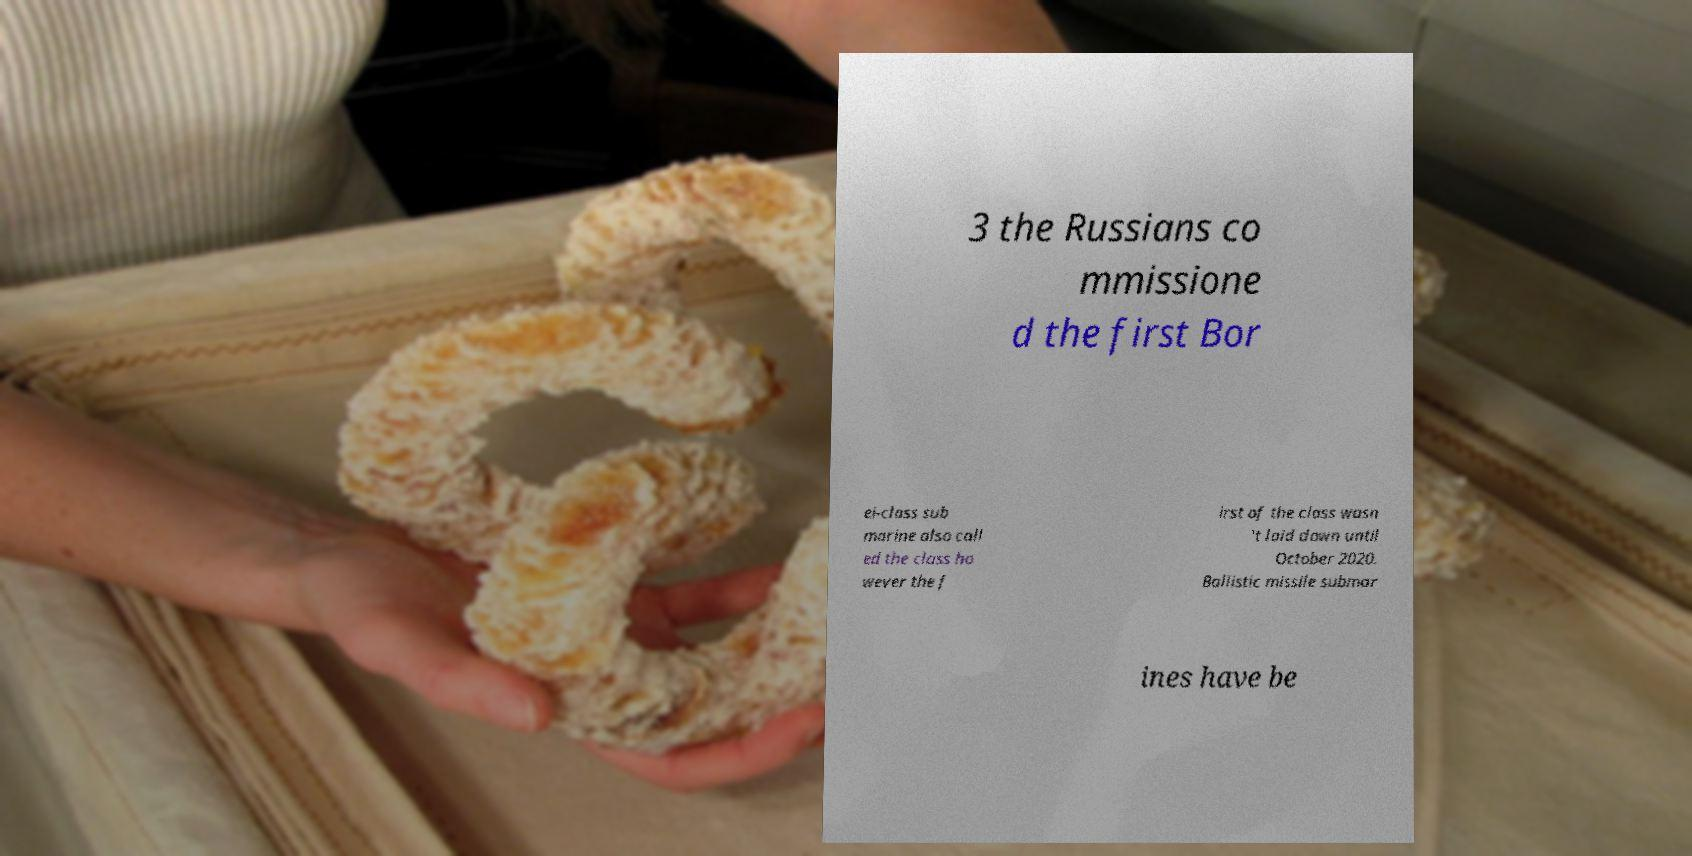I need the written content from this picture converted into text. Can you do that? 3 the Russians co mmissione d the first Bor ei-class sub marine also call ed the class ho wever the f irst of the class wasn 't laid down until October 2020. Ballistic missile submar ines have be 